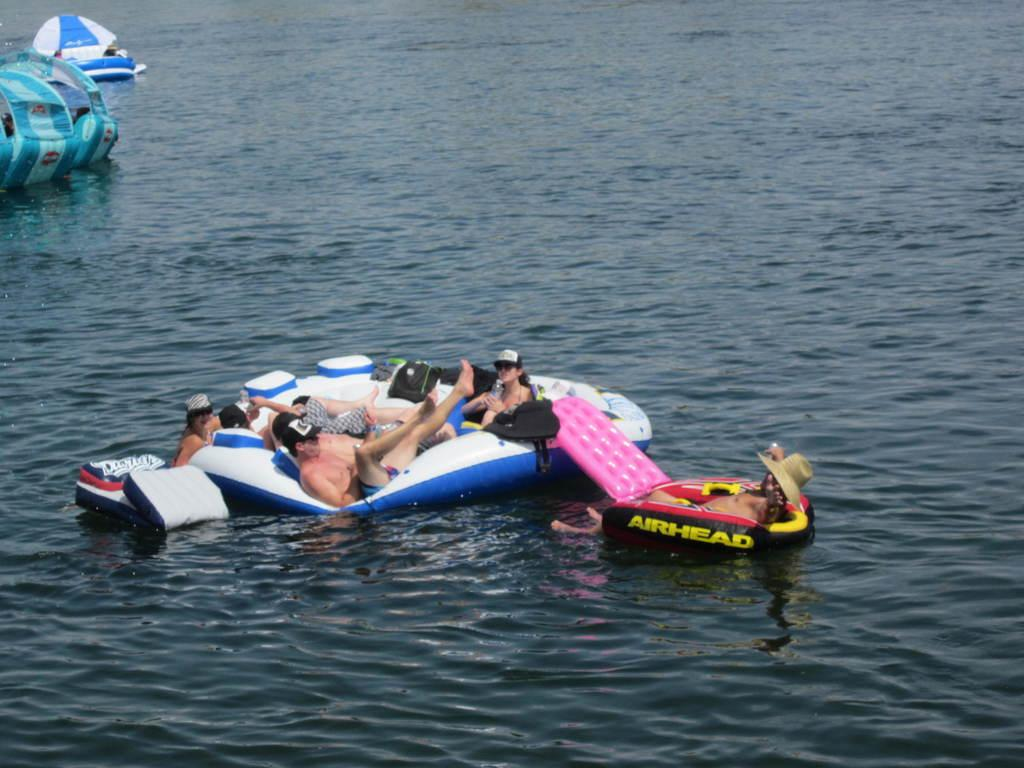<image>
Provide a brief description of the given image. Group of people on air balloons that says Airhead. 